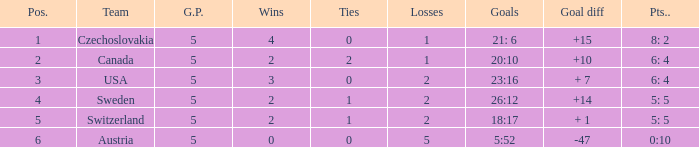When the g.p was above 5, what was the largest tie? None. 